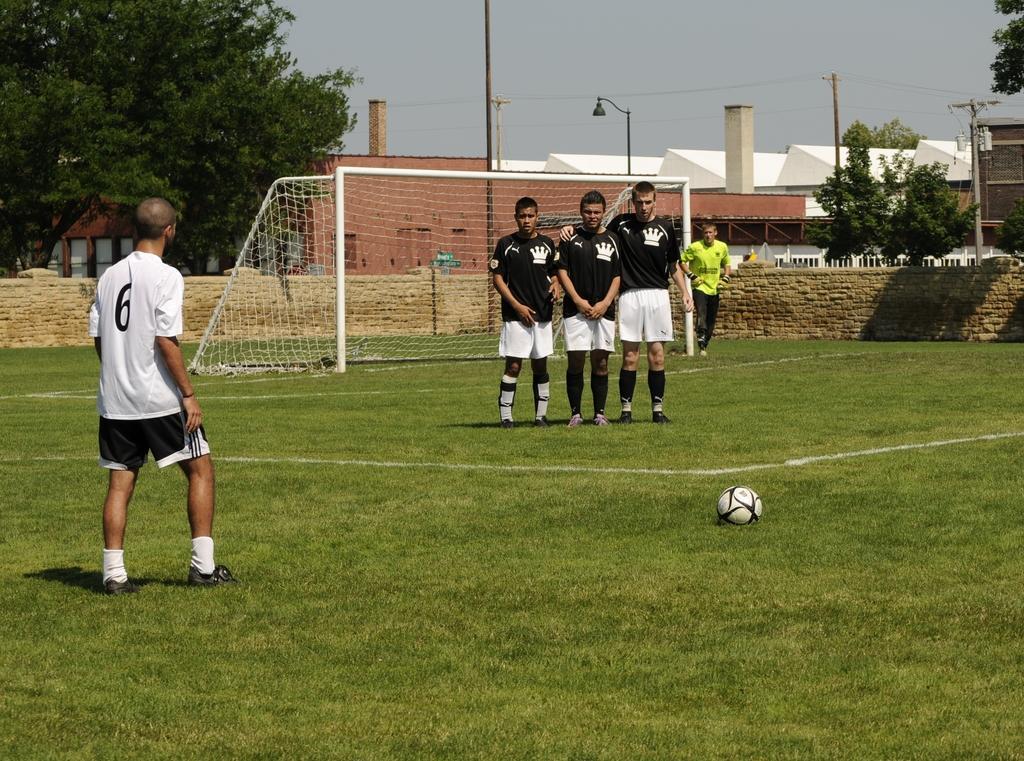Could you give a brief overview of what you see in this image? There are five persons on the ground. This is grass and there is a ball. In the background we can see a mesh, wall, trees, poles, houses, and sky. 